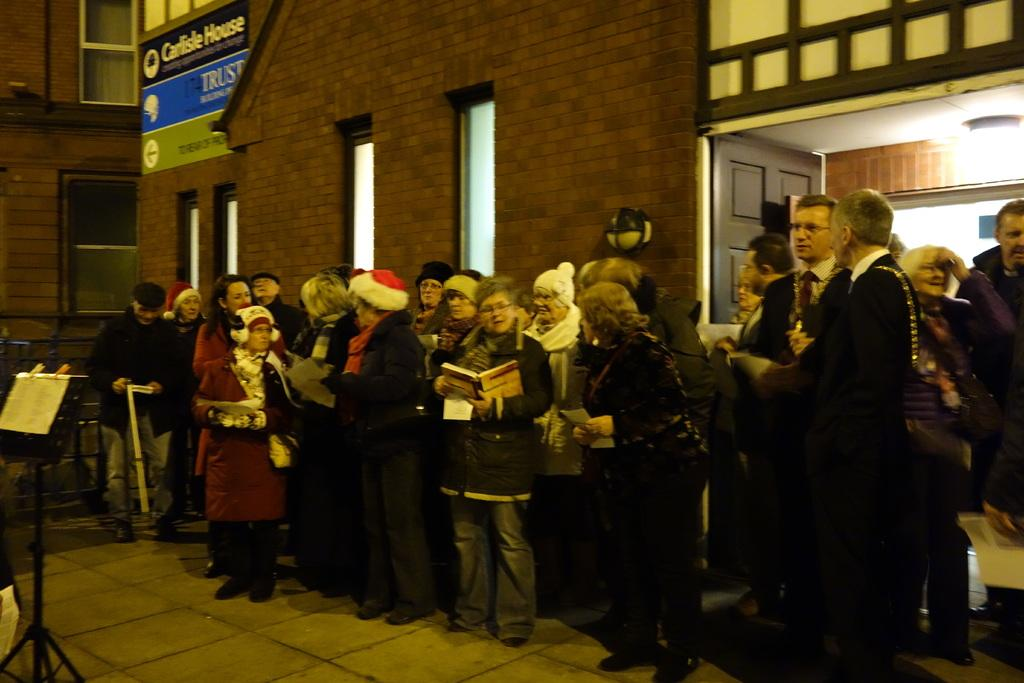What can be seen in the image involving people? There are people standing in the image. What is a prominent feature of the background in the image? There is a wall in the image with windows on it. Are there any informational or directional elements in the image? Yes, there are sign boards in the image. What is located on the left side of the image? There is a black color stand on the left side of the image. What type of farmer can be seen working in the fields in the image? There are no farmers or fields present in the image. How many waves can be seen crashing on the shore in the image? There are no waves or shoreline present in the image. 